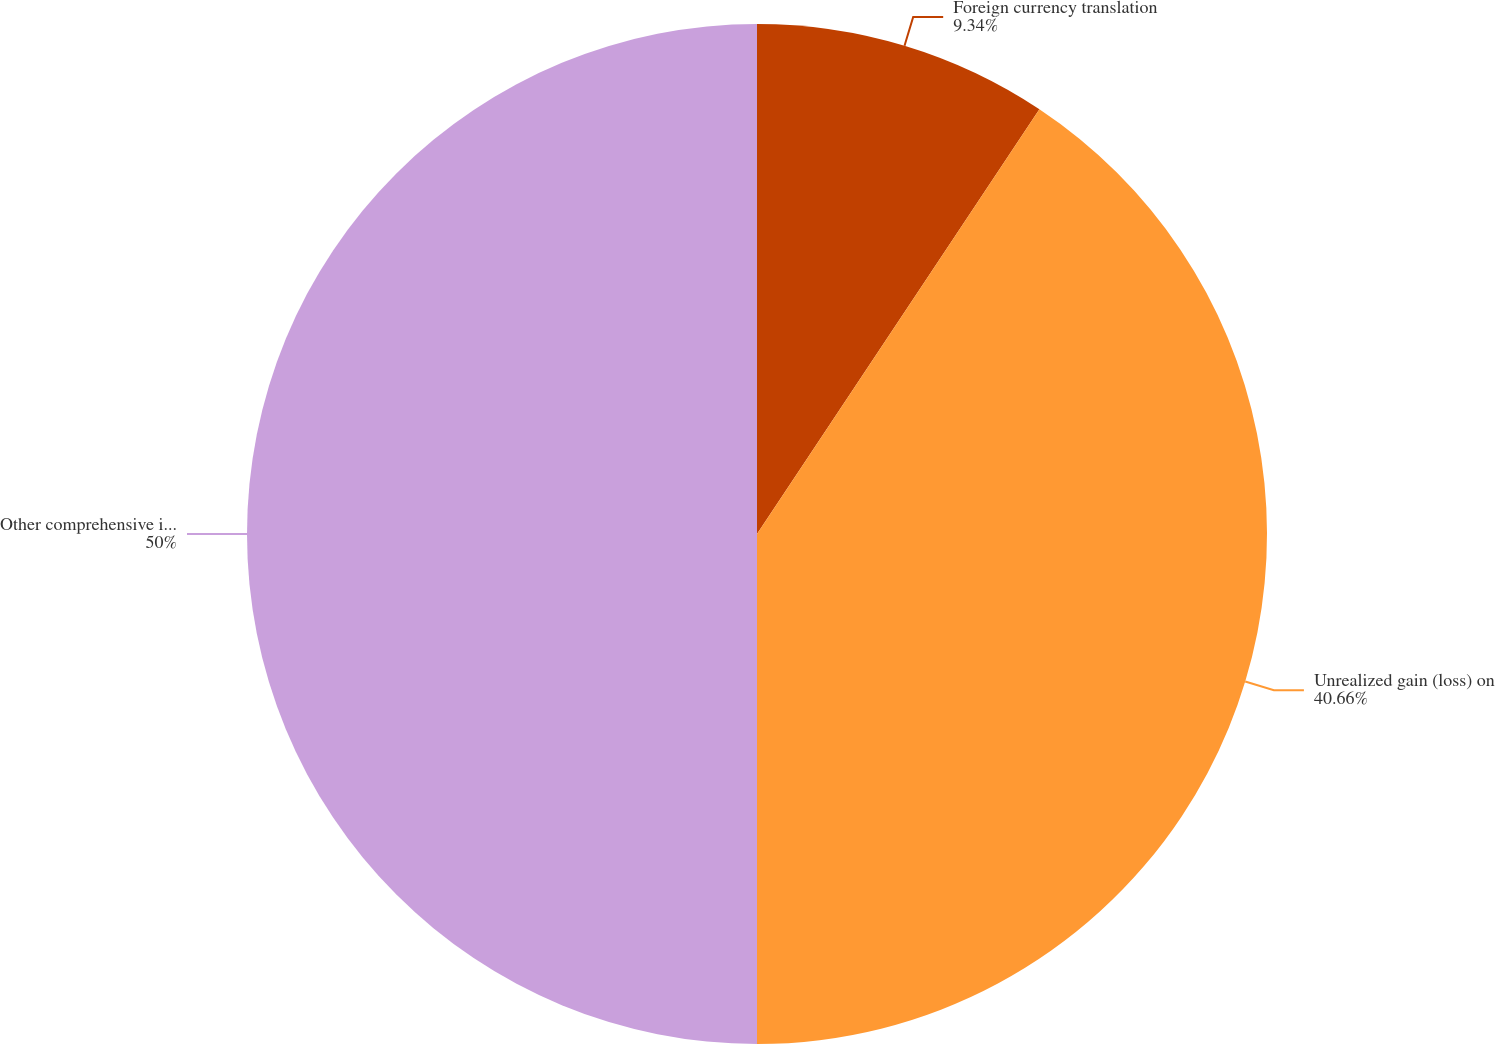Convert chart. <chart><loc_0><loc_0><loc_500><loc_500><pie_chart><fcel>Foreign currency translation<fcel>Unrealized gain (loss) on<fcel>Other comprehensive income<nl><fcel>9.34%<fcel>40.66%<fcel>50.0%<nl></chart> 